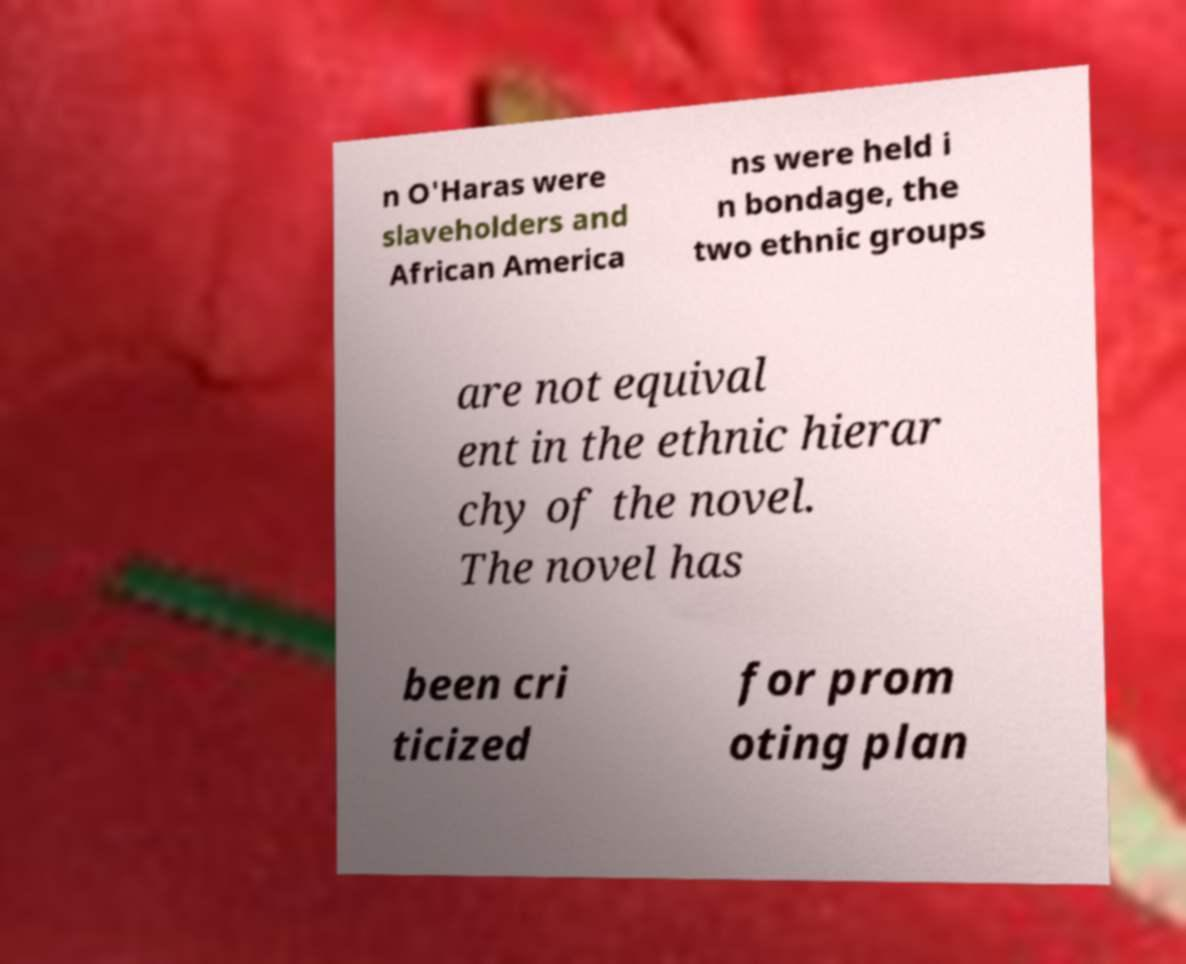For documentation purposes, I need the text within this image transcribed. Could you provide that? n O'Haras were slaveholders and African America ns were held i n bondage, the two ethnic groups are not equival ent in the ethnic hierar chy of the novel. The novel has been cri ticized for prom oting plan 